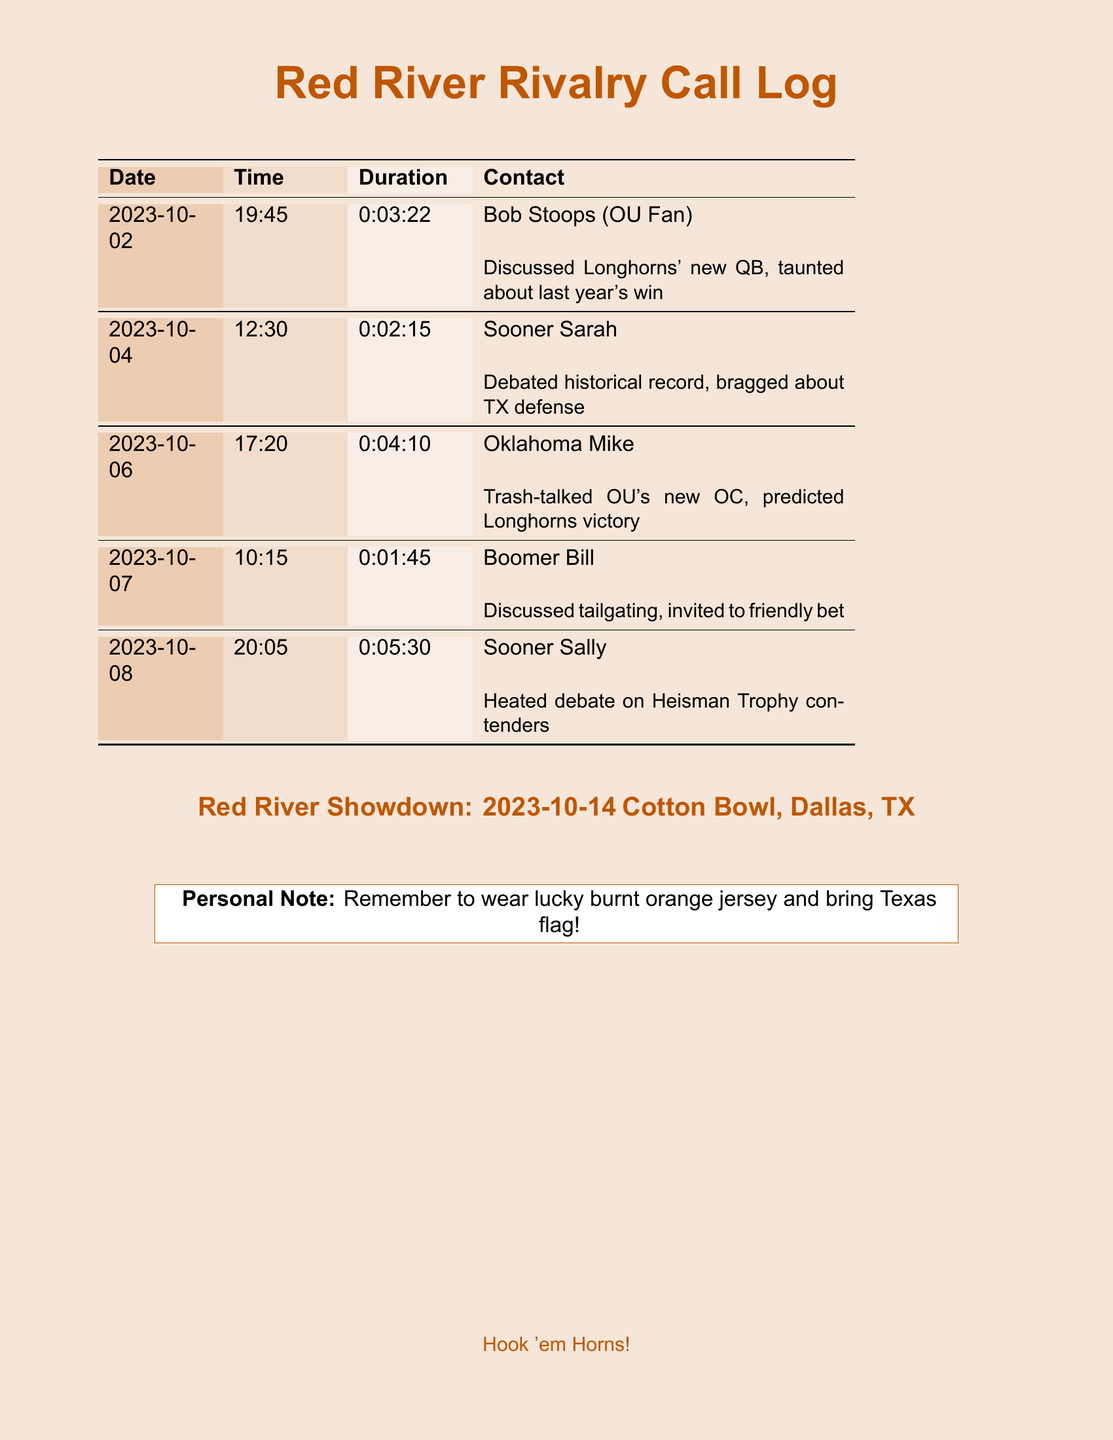What is the date of the first call? The date of the first call is listed at the top of the call log.
Answer: 2023-10-02 Who was contacted on October 4? The entry for October 4 includes the name of the contact for that date.
Answer: Sooner Sarah What was the duration of the call with Oklahoma Mike? The duration can be found in the record of the call with Oklahoma Mike.
Answer: 0:04:10 How many calls were made in total? The total number of calls can be counted from the provided entries in the document.
Answer: 5 What topic was discussed with Bob Stoops? The document notes the discussion topic during the call with Bob Stoops.
Answer: Longhorns' new QB What time did the call with Sooner Sally start? The time for the call with Sooner Sally is recorded in the log entry.
Answer: 20:05 What is the location of the Red River Showdown? The location of the event is clearly stated in the document.
Answer: Cotton Bowl, Dallas, TX Who initiated the friendly bet mentioned in the call log? The friendly bet invitation is linked to the discussion with a specific contact in the document.
Answer: Boomer Bill What is the personal note reminder related to the game? The personal note in the document specifies what to remember for the game day.
Answer: Wear lucky burnt orange jersey and bring Texas flag! 